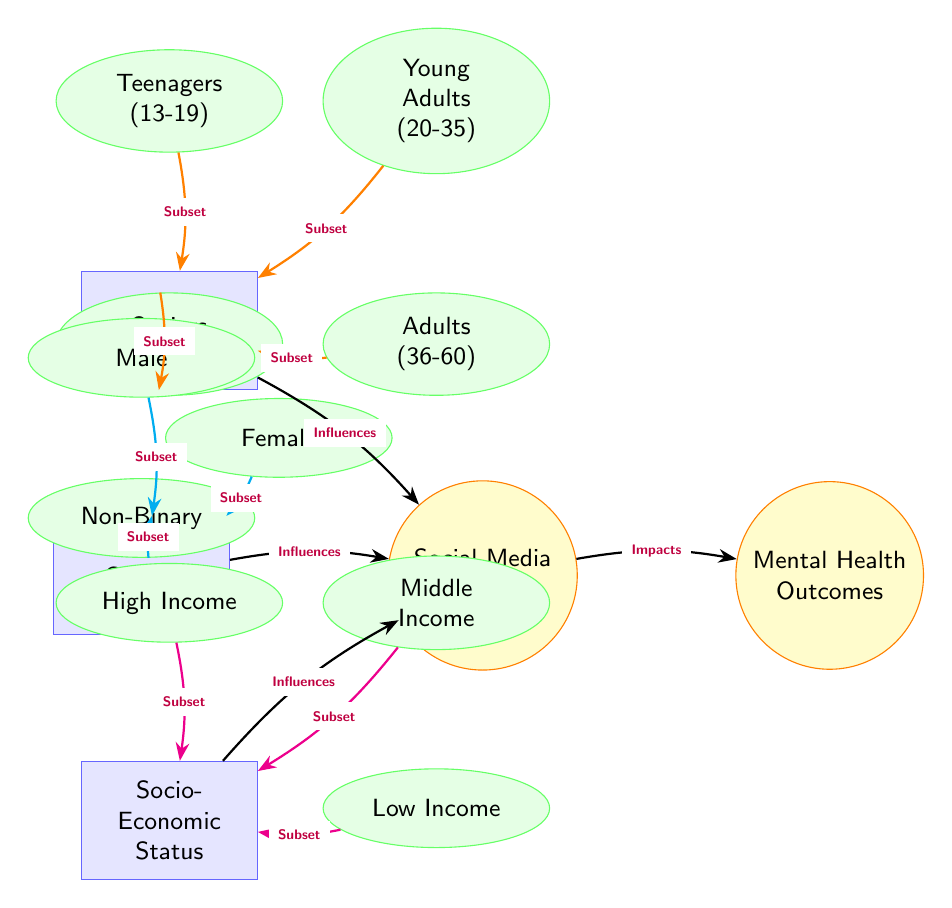What is the main topic of the diagram? The main topic is indicated by the first node, which is "Social Media Usage". This is the central theme connecting the factors and outcomes represented in the diagram.
Answer: Social Media Usage How many demographic factors influence social media usage? There are three demographic factors represented: Age Group, Gender, and Socio-Economic Status. Each one is a distinct rectangle leading into the main node for social media usage.
Answer: 3 Which age group is represented as teenagers? The age group representing teenagers is "Teenagers (13-19)", seen at the top of the age demographic section.
Answer: Teenagers (13-19) What influences mental health outcomes in the diagram? The arrow from the node "Social Media Usage" to "Mental Health Outcomes" indicates that social media usage impacts mental health outcomes.
Answer: Impacts Which gender subset is located directly below male? The gender subset located directly below male is "Female", as per its positional relation in the diagram.
Answer: Female How many age groups are represented in the diagram? The age groups represented, which are connected to the Age Group factor, are Teenagers, Young Adults, Adults, and Seniors, totaling four age groups.
Answer: 4 Which socio-economic status subset represents low income? The socio-economic status subset that represents low income is labeled "Low Income", located at the bottom of the socio-economic status section.
Answer: Low Income Which demographic factor has only three subsets? The socio-economic status factor consists of three subsets: High Income, Middle Income, and Low Income, distinguishing it from the other factors.
Answer: Socio-Economic Status What label connects Age Group to mental health outcomes? There is no direct arrow connecting Age Group to Mental Health Outcomes; instead, the factor "Age Group" influences "Social Media Usage", which then impacts Mental Health Outcomes, as stated along the connecting arrows.
Answer: Influences 